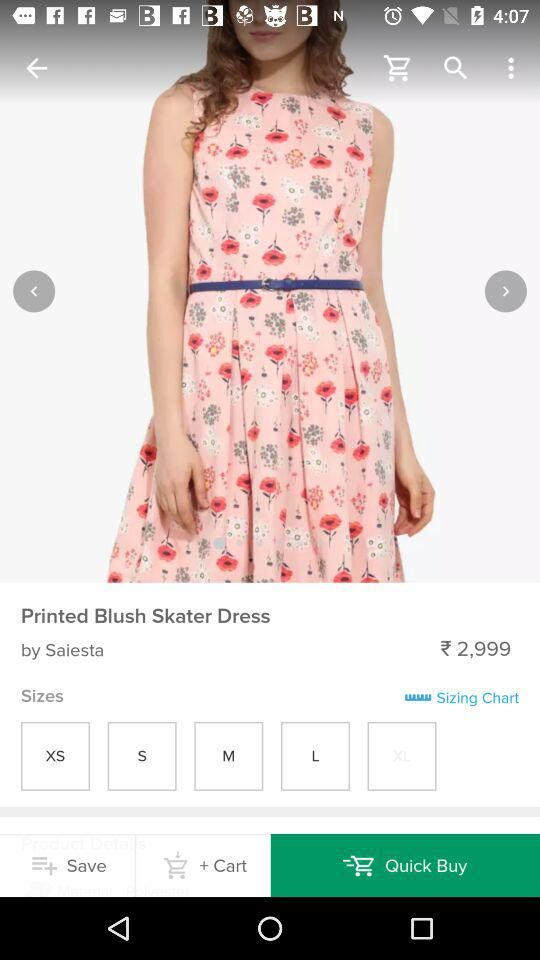How many sizes are available?
When the provided information is insufficient, respond with <no answer>. <no answer> 